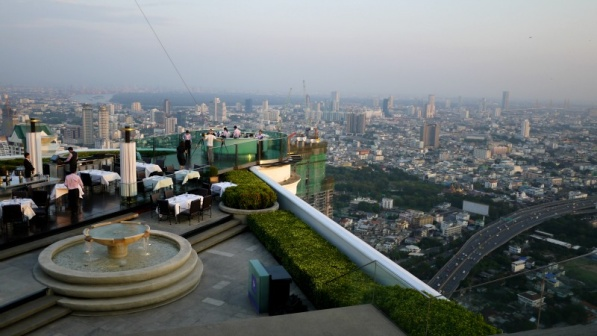What elements in this image point to the bar being a popular spot for gatherings? Several elements in the image indicate that this rooftop bar is a popular gathering spot. The well-arranged tables and chairs, each set up meticulously, suggest that the bar hosts many patrons regularly. The presence of multiple umbrellas for shade highlights a customer-focused design, aimed at providing comfort and enhancing the experience. The beautiful panoramic view of the city is another significant draw, likely attracting visitors who appreciate stunning vistas and a relaxed yet sophisticated ambiance. The centrally located fountain provides a tranquil focal point, adding to the appeal of the environment and encouraging longer stays for conversation and relaxation. 